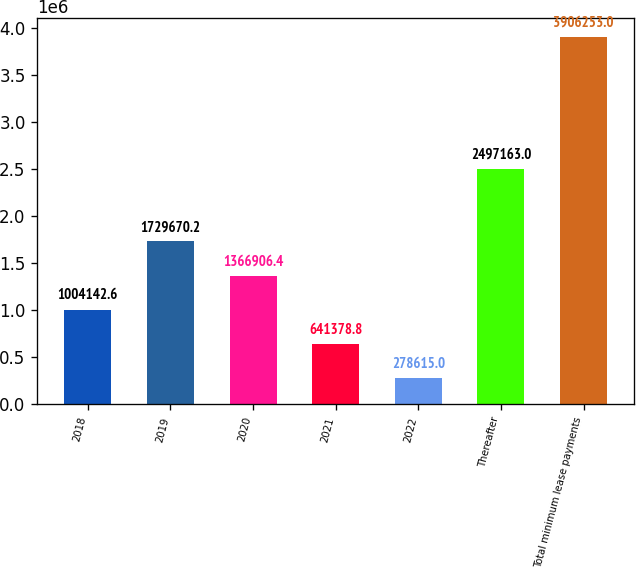Convert chart to OTSL. <chart><loc_0><loc_0><loc_500><loc_500><bar_chart><fcel>2018<fcel>2019<fcel>2020<fcel>2021<fcel>2022<fcel>Thereafter<fcel>Total minimum lease payments<nl><fcel>1.00414e+06<fcel>1.72967e+06<fcel>1.36691e+06<fcel>641379<fcel>278615<fcel>2.49716e+06<fcel>3.90625e+06<nl></chart> 